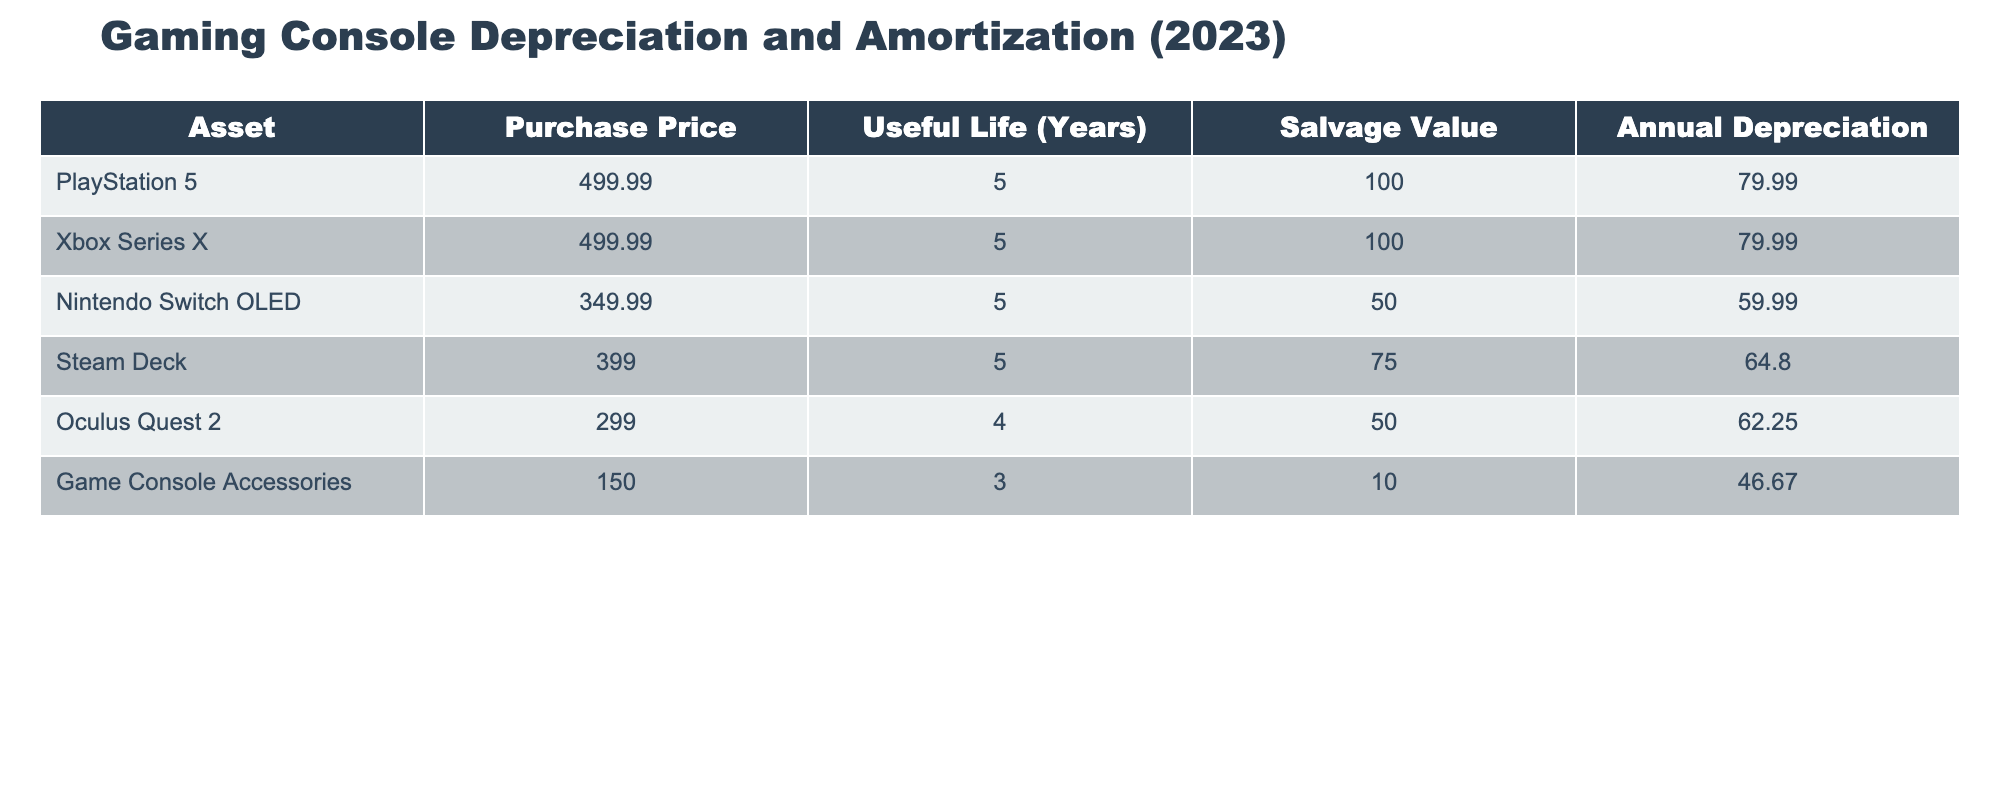What is the purchase price of the Steam Deck? The purchase price of the Steam Deck is listed directly in the table under the "Purchase Price" column.
Answer: 399.00 Which console has the highest annual depreciation? To determine which console has the highest annual depreciation, we compare the values in the "Annual Depreciation" column. The PlayStation 5, Xbox Series X, and Oculus Quest 2 all have different depreciation values, and comparing them shows that the PlayStation 5 and Xbox Series X both have the highest value of 79.99.
Answer: PlayStation 5 and Xbox Series X What is the total useful life of all consoles combined? To find the total useful life, we add the "Useful Life (Years)" values for all consoles. The sum is 5 (PS5) + 5 (Xbox Series X) + 5 (Nintendo Switch OLED) + 5 (Steam Deck) + 4 (Oculus Quest 2) + 3 (Game Console Accessories) = 27 years.
Answer: 27 Is the salvage value of the Nintendo Switch OLED greater than that of the Oculus Quest 2? The salvage value of the Nintendo Switch OLED is 50.00, while that of the Oculus Quest 2 is 50.00 as well. Since they are equal, the answer is no.
Answer: No What is the average annual depreciation of the consoles? To calculate the average annual depreciation, we sum the "Annual Depreciation" values: 79.99 + 79.99 + 59.99 + 64.80 + 62.25 + 46.67 = 392.69. We then divide by the number of consoles, which is 6. Therefore, 392.69 / 6 = 65.45.
Answer: 65.45 Which game console has the shortest useful life? To find the console with the shortest useful life, we look at the "Useful Life (Years)" column and find the minimum value. The Game Console Accessories have a useful life of 3 years, which is the shortest.
Answer: Game Console Accessories What is the difference in annual depreciation between the Xbox Series X and the Nintendo Switch OLED? The Xbox Series X has an annual depreciation of 79.99, while the Nintendo Switch OLED has 59.99. We find the difference by subtracting the latter from the former: 79.99 - 59.99 = 20.00.
Answer: 20.00 Is the purchase price of the Game Console Accessories less than 200? The purchase price of the Game Console Accessories is 150.00, which is indeed less than 200.
Answer: Yes Which console has the lowest salvage value? The lowest salvage value can be found by comparing the values in the "Salvage Value" column. The Nintendo Switch OLED has a salvage value of 50.00, matching that of the Oculus Quest 2, which are both the lowest.
Answer: Nintendo Switch OLED and Oculus Quest 2 